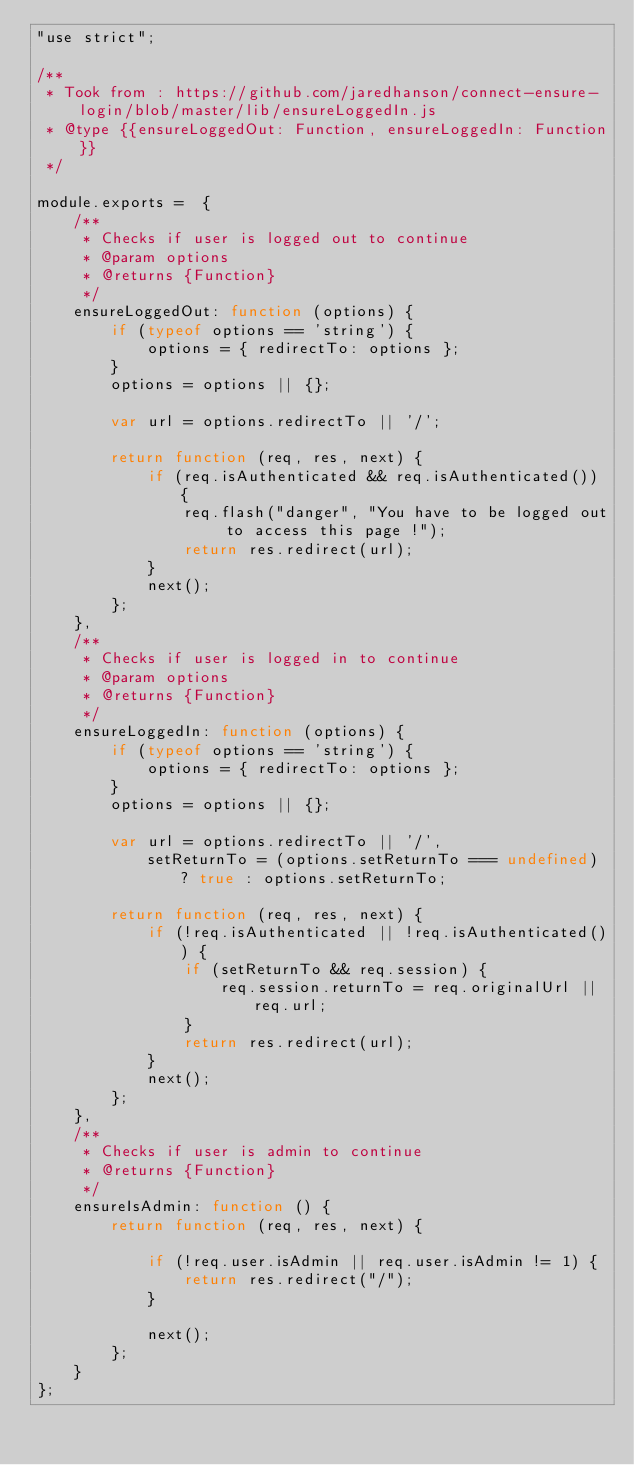<code> <loc_0><loc_0><loc_500><loc_500><_JavaScript_>"use strict";

/**
 * Took from : https://github.com/jaredhanson/connect-ensure-login/blob/master/lib/ensureLoggedIn.js
 * @type {{ensureLoggedOut: Function, ensureLoggedIn: Function}}
 */

module.exports =  {
    /**
     * Checks if user is logged out to continue
     * @param options
     * @returns {Function}
     */
    ensureLoggedOut: function (options) {
        if (typeof options == 'string') {
            options = { redirectTo: options };
        }
        options = options || {};

        var url = options.redirectTo || '/';

        return function (req, res, next) {
            if (req.isAuthenticated && req.isAuthenticated()) {
                req.flash("danger", "You have to be logged out to access this page !");
                return res.redirect(url);
            }
            next();
        };
    },
    /**
     * Checks if user is logged in to continue
     * @param options
     * @returns {Function}
     */
    ensureLoggedIn: function (options) {
        if (typeof options == 'string') {
            options = { redirectTo: options };
        }
        options = options || {};

        var url = options.redirectTo || '/',
            setReturnTo = (options.setReturnTo === undefined) ? true : options.setReturnTo;

        return function (req, res, next) {
            if (!req.isAuthenticated || !req.isAuthenticated()) {
                if (setReturnTo && req.session) {
                    req.session.returnTo = req.originalUrl || req.url;
                }
                return res.redirect(url);
            }
            next();
        };
    },
    /**
     * Checks if user is admin to continue
     * @returns {Function}
     */
    ensureIsAdmin: function () {
        return function (req, res, next) {

            if (!req.user.isAdmin || req.user.isAdmin != 1) {
                return res.redirect("/");
            }

            next();
        };
    }
};</code> 